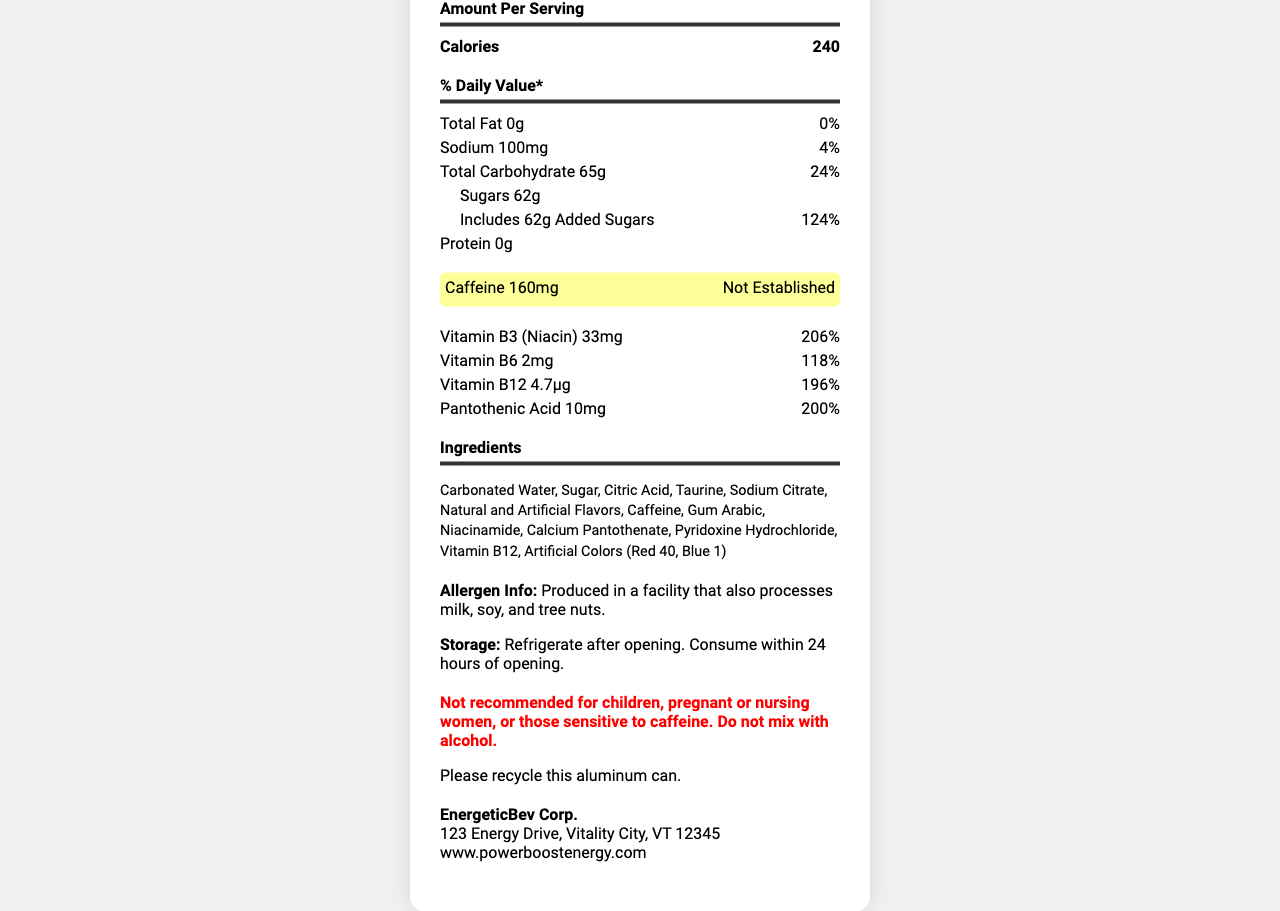what is the serving size of PowerBoost Energy Drink? The serving size is given directly in the document under the "Serving Size" section.
Answer: 1 can (473 mL) how many calories are in one serving? The number of calories per serving is listed in the "Amount Per Serving" section as 240.
Answer: 240 what is the percentage of daily value for total carbohydrate? The percentage daily value for total carbohydrate is clearly indicated in the "% Daily Value" section as 24%.
Answer: 24% how much caffeine does the drink contain? The caffeine content of the drink is specifically highlighted in the document as 160mg.
Answer: 160mg what are the ingredients in the PowerBoost Energy Drink? The ingredients are listed in the "Ingredients" section of the document.
Answer: Carbonated Water, Sugar, Citric Acid, Taurine, Sodium Citrate, Natural and Artificial Flavors, Caffeine, Gum Arabic, Niacinamide, Calcium Pantothenate, Pyridoxine Hydrochloride, Vitamin B12, Artificial Colors (Red 40, Blue 1) which vitamins are included in the energy drink? The vitamins included in the energy drink are listed under the "vitamins_and_minerals" section: Vitamin B3 (Niacin), Vitamin B6, Vitamin B12, and Pantothenic Acid.
Answer: Vitamin B3 (Niacin), Vitamin B6, Vitamin B12, Pantothenic Acid what percentage of the daily value does Vitamin B3 (Niacin) provide? A. 100% B. 118% C. 196% D. 206% The percentage daily value for Vitamin B3 (Niacin) is listed as 206%.
Answer: D what could be a potential allergen in the drink? A. Gluten B. Soy C. Peanuts D. Eggs The allergen information states that the product is produced in a facility that also processes milk, soy, and tree nuts.
Answer: B is PowerBoost Energy Drink recommended for pregnant women? The warning section explicitly states that the drink is not recommended for children, pregnant or nursing women, or those sensitive to caffeine.
Answer: No describe the main idea of the document. The document provides comprehensive nutritional and ingredient details for the PowerBoost Energy Drink, aiming to inform consumers about its contents and any potential health considerations.
Answer: The document is a detailed Nutrition Facts Label for a popular energy drink, PowerBoost Energy Drink. It includes information about the serving size, calories, macronutrients, caffeine content, vitamins, ingredients, allergen information, storage instructions, warnings, recycling information, and manufacturer details. how many grams of added sugars are in the drink? The "Added Sugars" section specifically lists 62g of added sugars.
Answer: 62g how much protein is in one serving? The "Protein" section indicates that there is 0g of protein.
Answer: 0g what is the company address for EnergeticBev Corp.? The manufacturer's address is listed in the document under the "manufacturer_info" section.
Answer: 123 Energy Drive, Vitality City, VT 12345 can this drink be mixed with alcohol? The warning section states, "Do not mix with alcohol."
Answer: No how much total fat is in one serving? The "Total Fat" section lists the amount as 0g.
Answer: 0g which information is missing regarding the drink's caffeine content? The daily value percentage for caffeine is listed as "Not Established," so it's not provided in the document.
Answer: Daily Value Percentage 